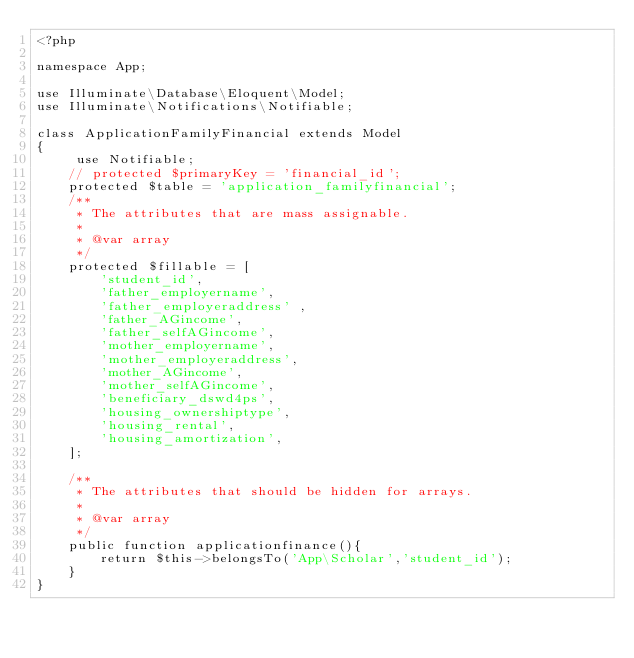Convert code to text. <code><loc_0><loc_0><loc_500><loc_500><_PHP_><?php

namespace App;

use Illuminate\Database\Eloquent\Model;
use Illuminate\Notifications\Notifiable;

class ApplicationFamilyFinancial extends Model
{
     use Notifiable;
    // protected $primaryKey = 'financial_id';
    protected $table = 'application_familyfinancial';
    /**
     * The attributes that are mass assignable.
     *
     * @var array
     */
    protected $fillable = [
 		'student_id',
    	'father_employername',
        'father_employeraddress' ,
        'father_AGincome',
        'father_selfAGincome',
        'mother_employername',
        'mother_employeraddress',
        'mother_AGincome',
        'mother_selfAGincome',
        'beneficiary_dswd4ps',
        'housing_ownershiptype',
        'housing_rental',
        'housing_amortization',       
    ];

    /**
     * The attributes that should be hidden for arrays.
     *
     * @var array
     */
    public function applicationfinance(){
        return $this->belongsTo('App\Scholar','student_id');
    }
}</code> 